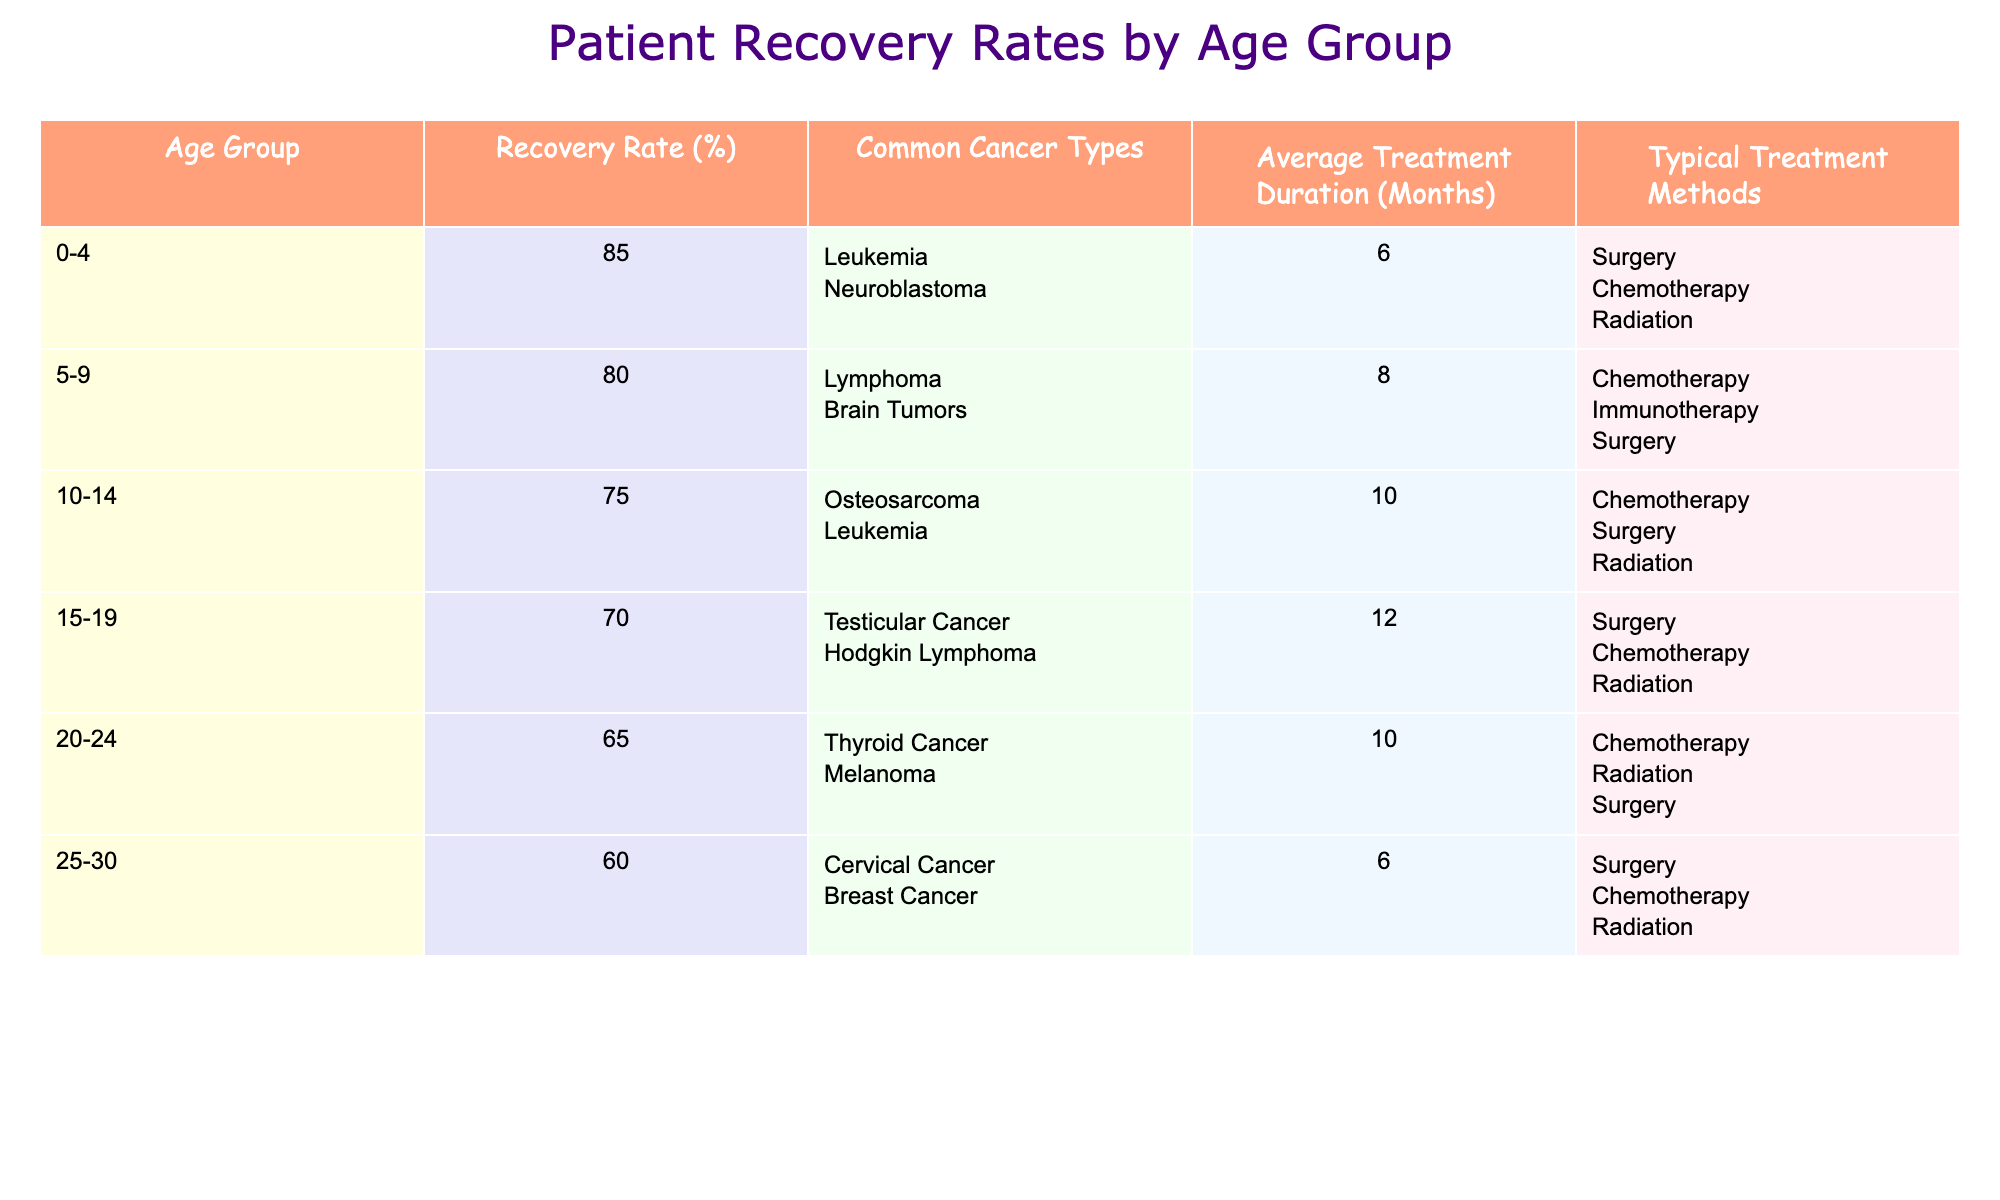What is the recovery rate for the age group 10-14? The table shows that the recovery rate for the age group 10-14 is 75%.
Answer: 75% Which common cancer type for the 0-4 age group has the highest recovery rate? According to the table, the age group 0-4 has a recovery rate of 85% for leukemia and neuroblastoma. Leukemia is commonly associated with the higher recovery rate.
Answer: Leukemia What is the average treatment duration for patients aged 15-19? For the age group 15-19, the table indicates the average treatment duration is 12 months.
Answer: 12 months Is the recovery rate for the 20-24 age group higher than that for the 15-19 age group? The recovery rate for the 20-24 age group is 65%, and for the 15-19 age group, it is 70%. Therefore, 65% is lower than 70%.
Answer: No What is the difference in recovery rates between the age groups 0-4 and 10-14? The recovery rate for the 0-4 age group is 85% and for the 10-14 age group is 75%. The difference is 85% - 75% = 10%.
Answer: 10% How many months, on average, does treatment last for patients in the 5-9 age group? The table states that the average treatment duration for the 5-9 age group is 8 months.
Answer: 8 months Which age group has the lowest recovery rate? The table shows that the age group 25-30 has the lowest recovery rate at 60%.
Answer: 25-30 If we combine the recovery rates for age groups 15-19 and 20-24, what is their average recovery rate? The recovery rate for 15-19 is 70% and for 20-24 is 65%. To find the average: (70% + 65%) / 2 = 67.5%.
Answer: 67.5% Does the recovery rate decrease consistently with increasing age groups? Looking at the table shows that recovery rates do decrease generally as age increases, from 85% (0-4) to 60% (25-30), indicating a trend of decreasing recovery rates.
Answer: Yes 